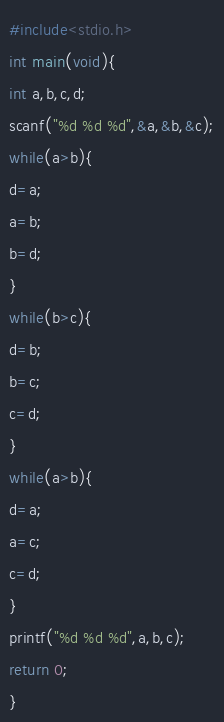<code> <loc_0><loc_0><loc_500><loc_500><_C_>#include<stdio.h>
int main(void){
int a,b,c,d;
scanf("%d %d %d",&a,&b,&c);
while(a>b){
d=a;
a=b;
b=d;
}
while(b>c){
d=b;
b=c;
c=d;
}
while(a>b){
d=a;
a=c;
c=d;
}
printf("%d %d %d",a,b,c);
return 0;
}
</code> 